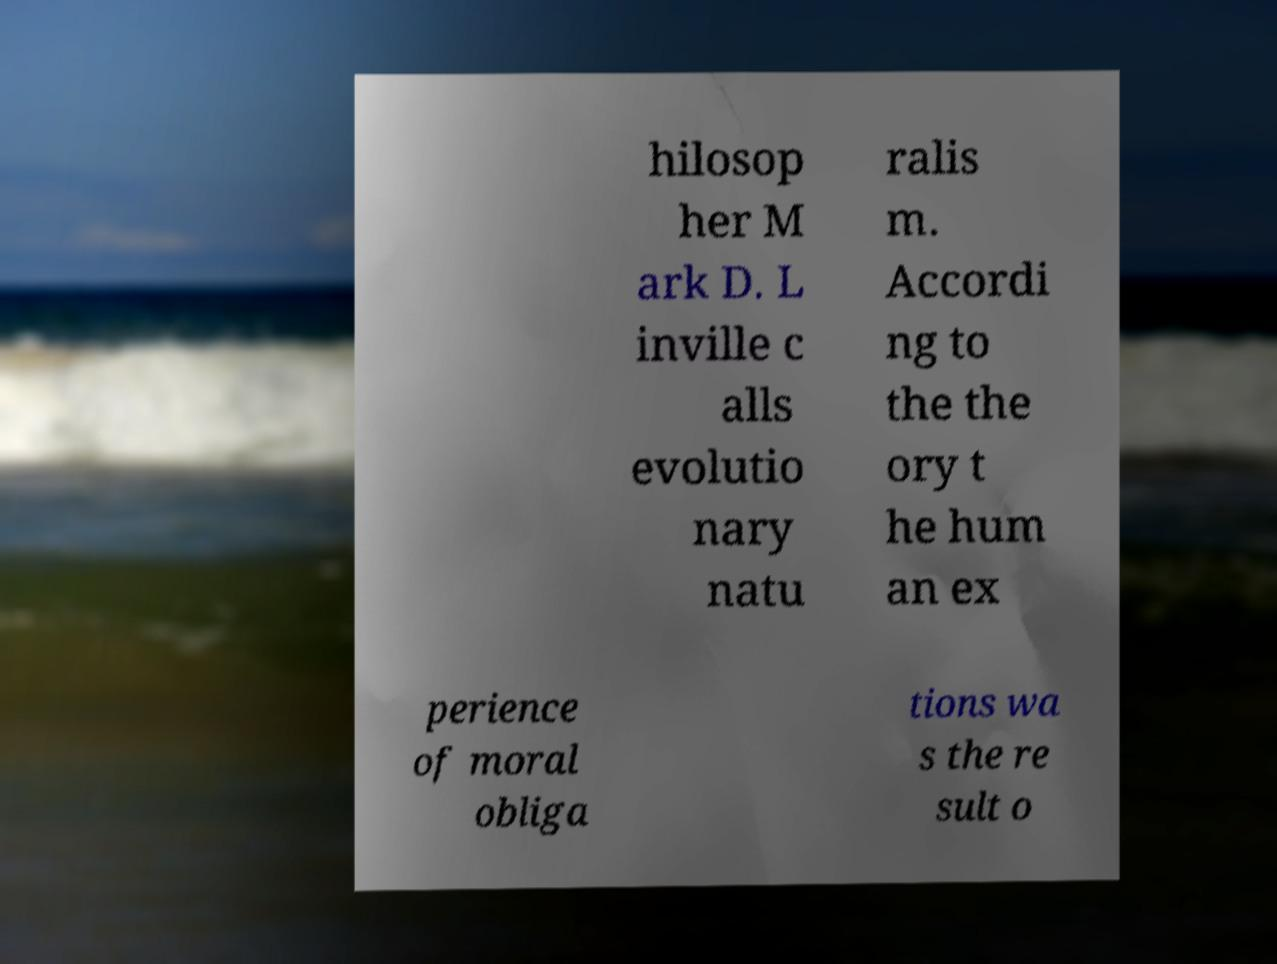Please read and relay the text visible in this image. What does it say? hilosop her M ark D. L inville c alls evolutio nary natu ralis m. Accordi ng to the the ory t he hum an ex perience of moral obliga tions wa s the re sult o 